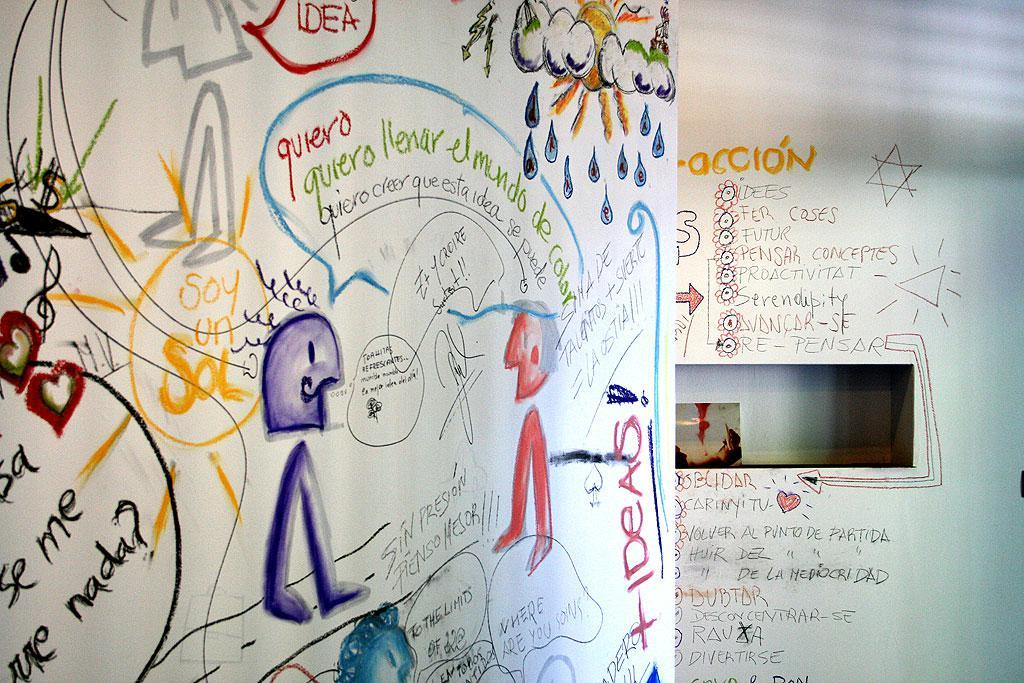What is depicted on the white paper in the image? There are drawings on a white paper in the image. What else can be seen on the white paper besides the drawings? There is text written on the white paper. Where is the image located in the scene? The image appears to be on a white wall. What else can be seen on the white wall besides the image? There is text written on the white wall on the right side. Can you see a flock of birds flying across the white wall in the image? There are no birds or flocks visible in the image; it only features drawings, text, and a white wall. What type of wrench is being used to draw on the white paper in the image? There is no wrench present in the image; it only features drawings, text, and a white wall. 